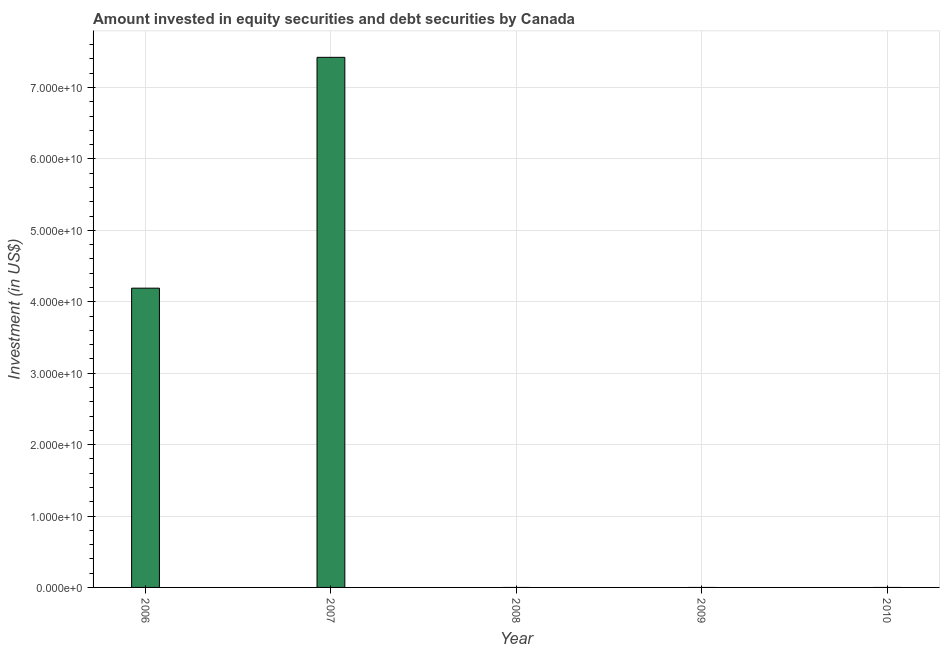Does the graph contain any zero values?
Provide a succinct answer. Yes. Does the graph contain grids?
Your answer should be compact. Yes. What is the title of the graph?
Make the answer very short. Amount invested in equity securities and debt securities by Canada. What is the label or title of the Y-axis?
Make the answer very short. Investment (in US$). What is the portfolio investment in 2006?
Your response must be concise. 4.19e+1. Across all years, what is the maximum portfolio investment?
Your response must be concise. 7.42e+1. What is the sum of the portfolio investment?
Offer a terse response. 1.16e+11. What is the average portfolio investment per year?
Your answer should be compact. 2.32e+1. In how many years, is the portfolio investment greater than 72000000000 US$?
Provide a succinct answer. 1. What is the difference between the highest and the lowest portfolio investment?
Your answer should be compact. 7.42e+1. What is the difference between two consecutive major ticks on the Y-axis?
Your response must be concise. 1.00e+1. What is the Investment (in US$) of 2006?
Provide a short and direct response. 4.19e+1. What is the Investment (in US$) of 2007?
Your answer should be compact. 7.42e+1. What is the Investment (in US$) of 2009?
Make the answer very short. 0. What is the difference between the Investment (in US$) in 2006 and 2007?
Provide a short and direct response. -3.23e+1. What is the ratio of the Investment (in US$) in 2006 to that in 2007?
Your answer should be compact. 0.56. 